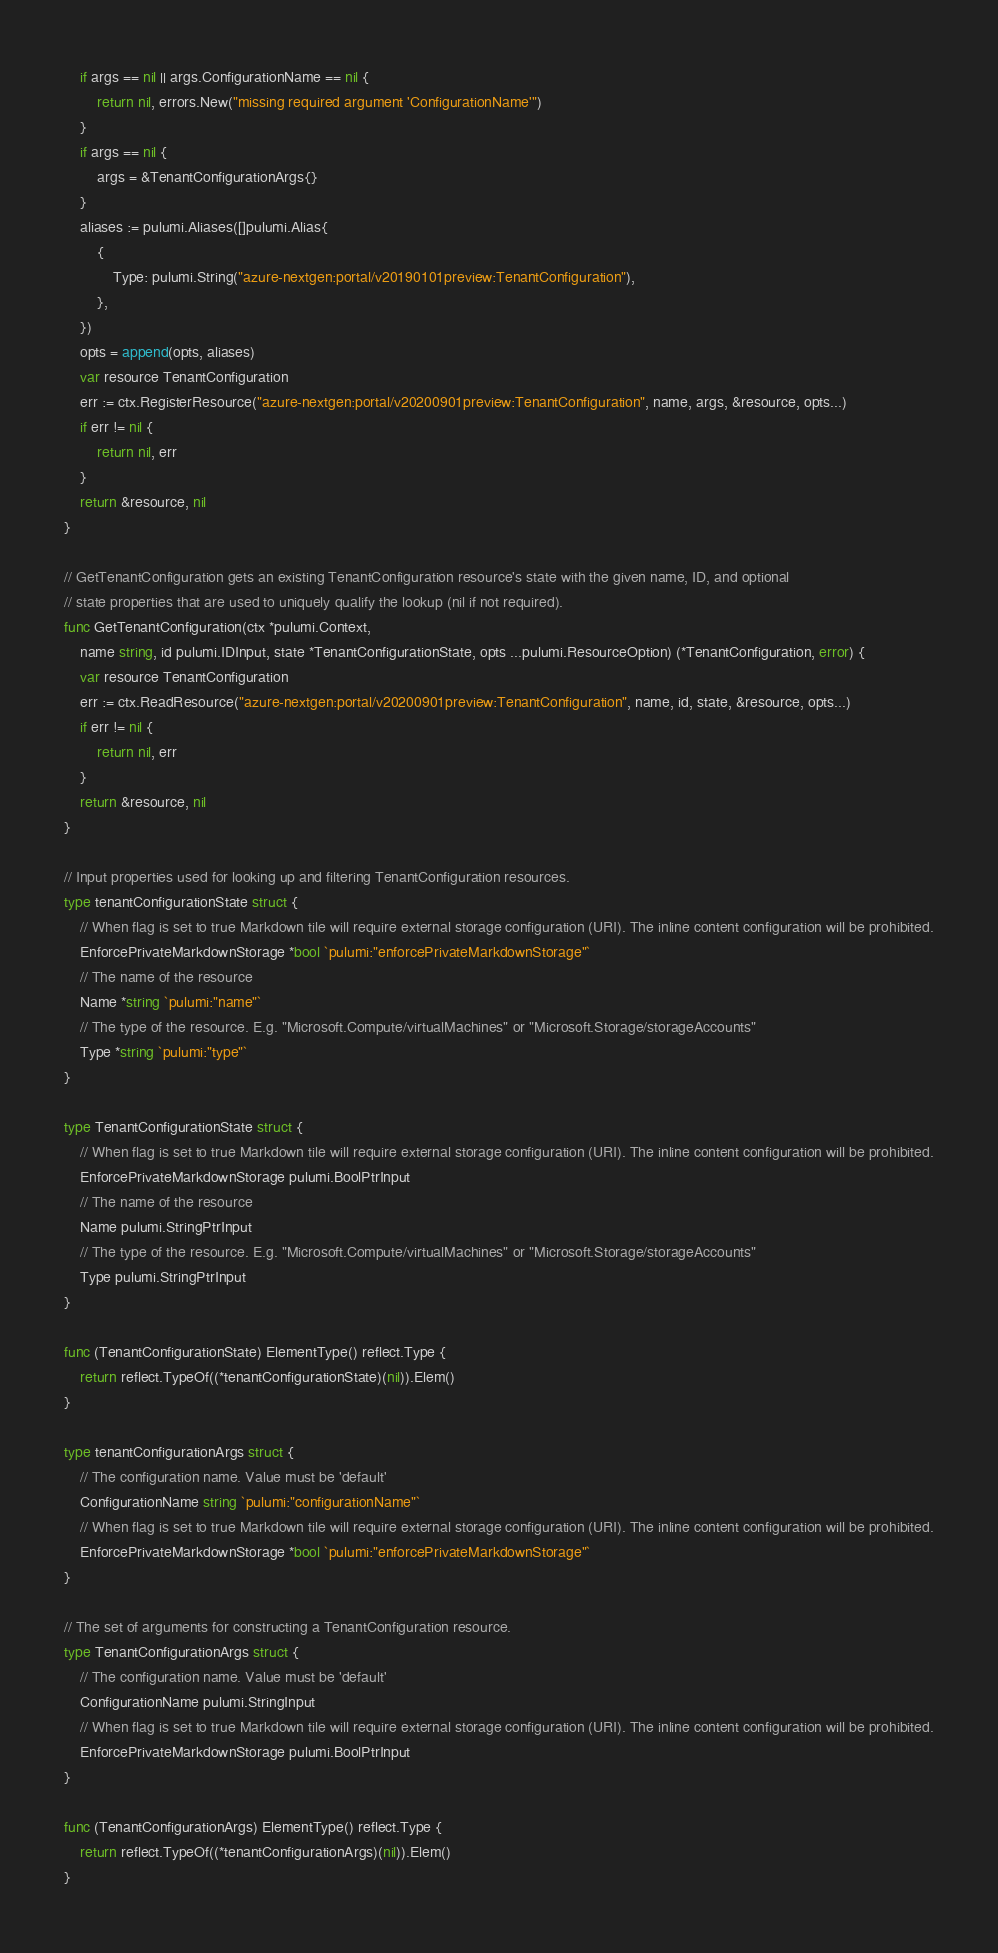<code> <loc_0><loc_0><loc_500><loc_500><_Go_>	if args == nil || args.ConfigurationName == nil {
		return nil, errors.New("missing required argument 'ConfigurationName'")
	}
	if args == nil {
		args = &TenantConfigurationArgs{}
	}
	aliases := pulumi.Aliases([]pulumi.Alias{
		{
			Type: pulumi.String("azure-nextgen:portal/v20190101preview:TenantConfiguration"),
		},
	})
	opts = append(opts, aliases)
	var resource TenantConfiguration
	err := ctx.RegisterResource("azure-nextgen:portal/v20200901preview:TenantConfiguration", name, args, &resource, opts...)
	if err != nil {
		return nil, err
	}
	return &resource, nil
}

// GetTenantConfiguration gets an existing TenantConfiguration resource's state with the given name, ID, and optional
// state properties that are used to uniquely qualify the lookup (nil if not required).
func GetTenantConfiguration(ctx *pulumi.Context,
	name string, id pulumi.IDInput, state *TenantConfigurationState, opts ...pulumi.ResourceOption) (*TenantConfiguration, error) {
	var resource TenantConfiguration
	err := ctx.ReadResource("azure-nextgen:portal/v20200901preview:TenantConfiguration", name, id, state, &resource, opts...)
	if err != nil {
		return nil, err
	}
	return &resource, nil
}

// Input properties used for looking up and filtering TenantConfiguration resources.
type tenantConfigurationState struct {
	// When flag is set to true Markdown tile will require external storage configuration (URI). The inline content configuration will be prohibited.
	EnforcePrivateMarkdownStorage *bool `pulumi:"enforcePrivateMarkdownStorage"`
	// The name of the resource
	Name *string `pulumi:"name"`
	// The type of the resource. E.g. "Microsoft.Compute/virtualMachines" or "Microsoft.Storage/storageAccounts"
	Type *string `pulumi:"type"`
}

type TenantConfigurationState struct {
	// When flag is set to true Markdown tile will require external storage configuration (URI). The inline content configuration will be prohibited.
	EnforcePrivateMarkdownStorage pulumi.BoolPtrInput
	// The name of the resource
	Name pulumi.StringPtrInput
	// The type of the resource. E.g. "Microsoft.Compute/virtualMachines" or "Microsoft.Storage/storageAccounts"
	Type pulumi.StringPtrInput
}

func (TenantConfigurationState) ElementType() reflect.Type {
	return reflect.TypeOf((*tenantConfigurationState)(nil)).Elem()
}

type tenantConfigurationArgs struct {
	// The configuration name. Value must be 'default'
	ConfigurationName string `pulumi:"configurationName"`
	// When flag is set to true Markdown tile will require external storage configuration (URI). The inline content configuration will be prohibited.
	EnforcePrivateMarkdownStorage *bool `pulumi:"enforcePrivateMarkdownStorage"`
}

// The set of arguments for constructing a TenantConfiguration resource.
type TenantConfigurationArgs struct {
	// The configuration name. Value must be 'default'
	ConfigurationName pulumi.StringInput
	// When flag is set to true Markdown tile will require external storage configuration (URI). The inline content configuration will be prohibited.
	EnforcePrivateMarkdownStorage pulumi.BoolPtrInput
}

func (TenantConfigurationArgs) ElementType() reflect.Type {
	return reflect.TypeOf((*tenantConfigurationArgs)(nil)).Elem()
}
</code> 